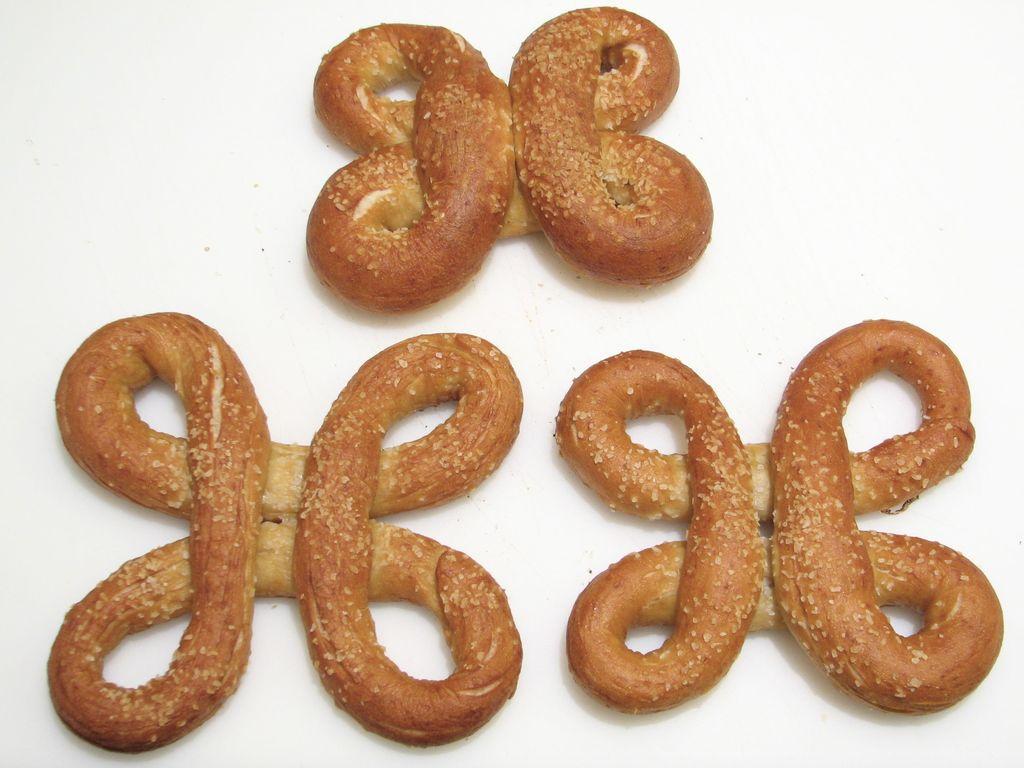Can you describe this image briefly? In this image we can see some food items which are called as pretzels. 